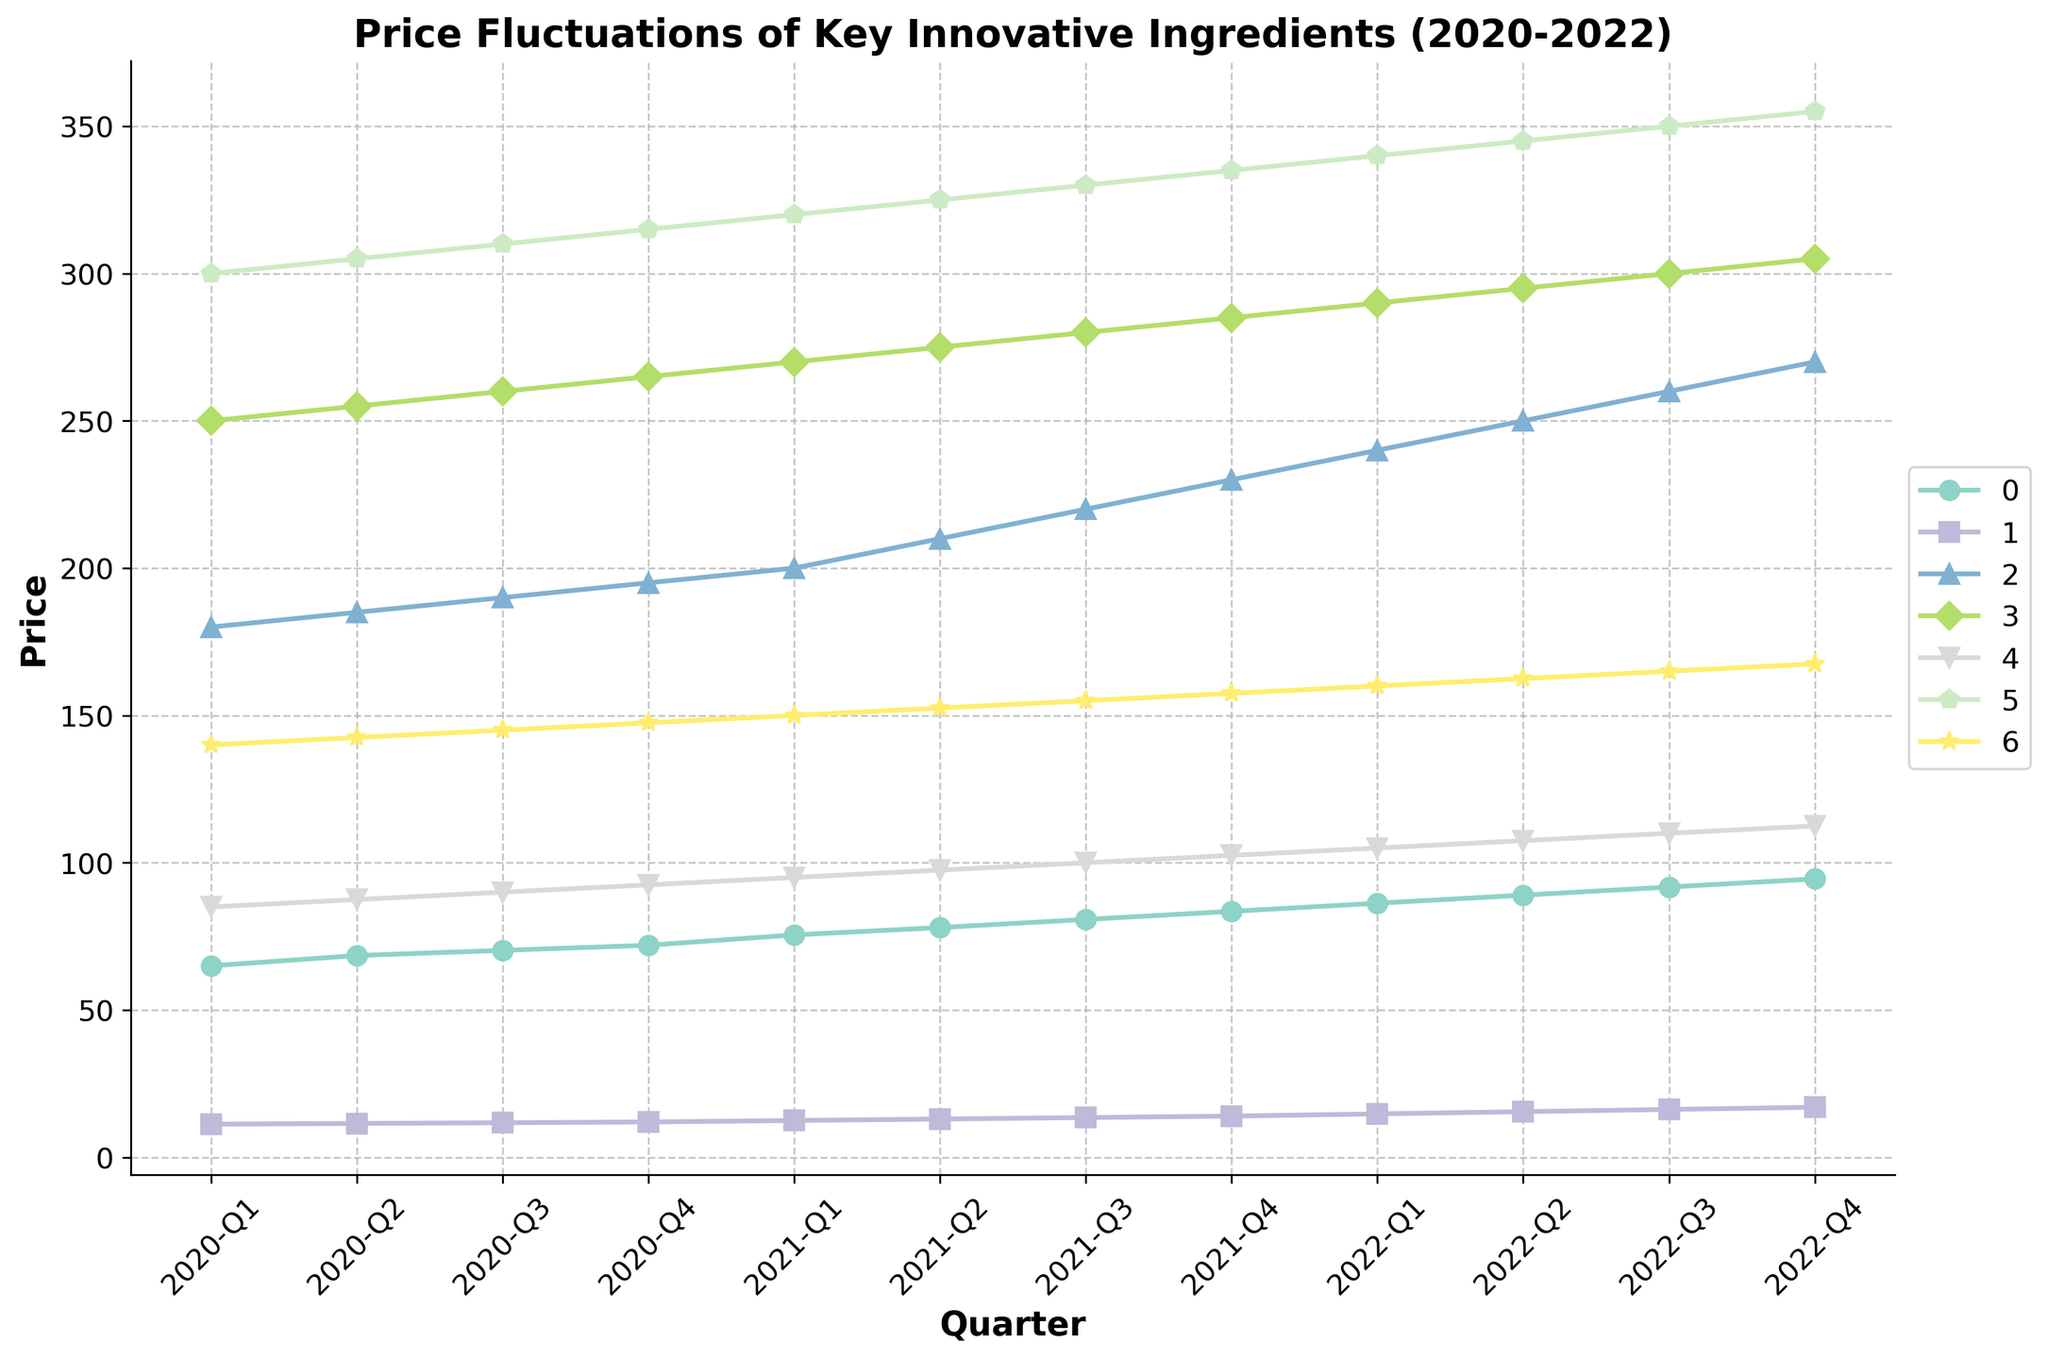What's the highest price recorded for Black Truffles and in which quarter? The highest price for Black Truffles can be observed by following the line representing Black Truffles over all quarters and identifying the peak point. According to the data, it peaks at $94.50 in 2022-Q4.
Answer: $94.50 in 2022-Q4 Which ingredient had the most significant price increase from 2020-Q1 to 2022-Q4? To find the ingredient with the most significant price increase, compute the difference between 2020-Q1 and 2022-Q4 for each ingredient. Kopi Luwak Coffee increases from $300.00 to $355.00, a total increase of $55.00. Wagyu Beef A5 increases from $180.00 to $270.00, a total increase of $90.00. Comparing all, Wagyu Beef A5 has the highest increase of $90.00.
Answer: Wagyu Beef A5 How much did Saffron's price change from 2020-Q2 to 2022-Q3? To find Saffron's price change, subtract its price in 2020-Q2 from its price in 2022-Q3. The price in 2020-Q2 was $11.50 and in 2022-Q3 it was $16.25. The change is $16.25 - $11.50 = $4.75.
Answer: $4.75 What is the average price of Beluga Caviar in 2021? To compute the average price of Beluga Caviar in 2021, sum the prices for all quarters in 2021 and then divide by 4. The prices are $270.00, $275.00, $280.00, and $285.00, so the sum is $1110.00. The average price is $1110.00 / 4 = $277.50.
Answer: $277.50 Which ingredient consistently increased in price every quarter without any decline? To determine which ingredient increased every quarter, examine the lines for any downward trends. Only Wagyu Beef A5 shows a continuous increase in price from $180.00 in 2020-Q1 to $270.00 in 2022-Q4 without any declines.
Answer: Wagyu Beef A5 Which quarter had the greatest price difference between the most and least expensive ingredients? To find the quarter with the greatest price difference between the most and least expensive ingredients, calculate the differences for each quarter. For instance, in 2020-Q1, the highest price is $300.00 (Kopi Luwak Coffee) and the lowest is $11.25 (Saffron), giving a difference of $288.75. Similarly, calculate for all quarters and compare to find the maximum difference. 2020-Q1 appears to have the greatest difference of $288.75.
Answer: 2020-Q1 What's the median price of Matsutake Mushrooms in 2022? To find the median price of Matsutake Mushrooms in 2022, list the prices for all quarters in 2022, which are $105.00, $107.50, $110.00, and $112.50. The median is the average of the two middle values: ($107.50 + $110.00) / 2 = $108.75.
Answer: $108.75 Did any ingredient's price surpass Kopi Luwak Coffee's price at any quarter? Kopi Luwak Coffee's price starts at $300.00 in 2020-Q1 and reaches $355.00 in 2022-Q4. Compare all other ingredients; none surpassed Kopi Luwak Coffee's price at any quarter.
Answer: No Between 2021-Q1 and 2022-Q1, which ingredient had the smallest price increase? Compare the price changes for all ingredients between 2021-Q1 and 2022-Q1. For instance, Black Truffles went from $75.50 to $86.25, increasing by $10.75. The smallest change can be observed for Jamón Ibérico de Bellota, which increased from $150.00 to $160.00, a change of $10.00.
Answer: Jamón Ibérico de Bellota 